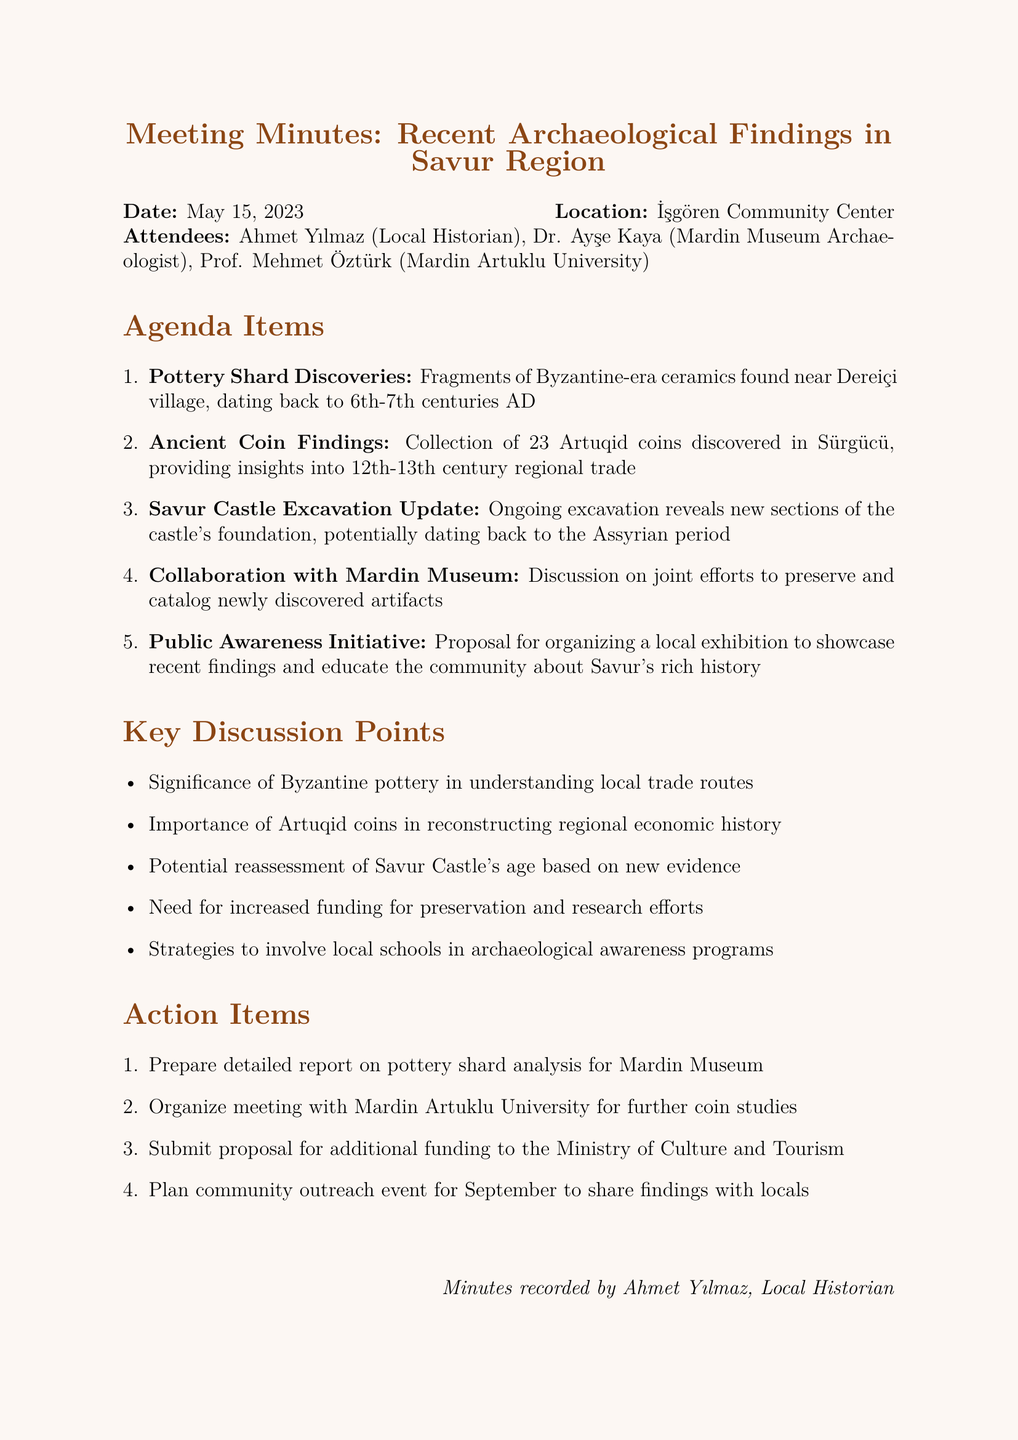What is the date of the meeting? The meeting took place on May 15, 2023, as specified in the document.
Answer: May 15, 2023 Who is the local historian in attendance? The local historian present at the meeting is identified as Ahmet Yılmaz.
Answer: Ahmet Yılmaz What type of coins were discovered in Sürgücü? The document mentions the collection of Artuqid coins found, which is a specific type of ancient coin.
Answer: Artuqid coins What is one proposal discussed for community engagement? The document outlines a proposal to organize a local exhibition to educate the community about the findings, indicating a focus on public awareness.
Answer: Local exhibition How many attendees were present at the meeting? Counting the list of attendees, there were three participants mentioned in the document.
Answer: 3 What period do the pottery shards date back to? The pottery shards are noted to date back to the 6th-7th centuries AD, providing a timeframe for the ceramic artifacts.
Answer: 6th-7th centuries AD Which university is involved in further studies on the ancient coins? The meeting minutes indicate that Mardin Artuklu University is involved in a follow-up meeting regarding the coins.
Answer: Mardin Artuklu University What is a key discussion point related to local trade? The significance of Byzantine pottery in understanding local trade routes is emphasized as a key discussion point.
Answer: Byzantine pottery What foundation is being explored in Savur? The document mentions ongoing excavations that reveal the foundation of Savur Castle, indicating archaeological work on this structure.
Answer: Savur Castle 